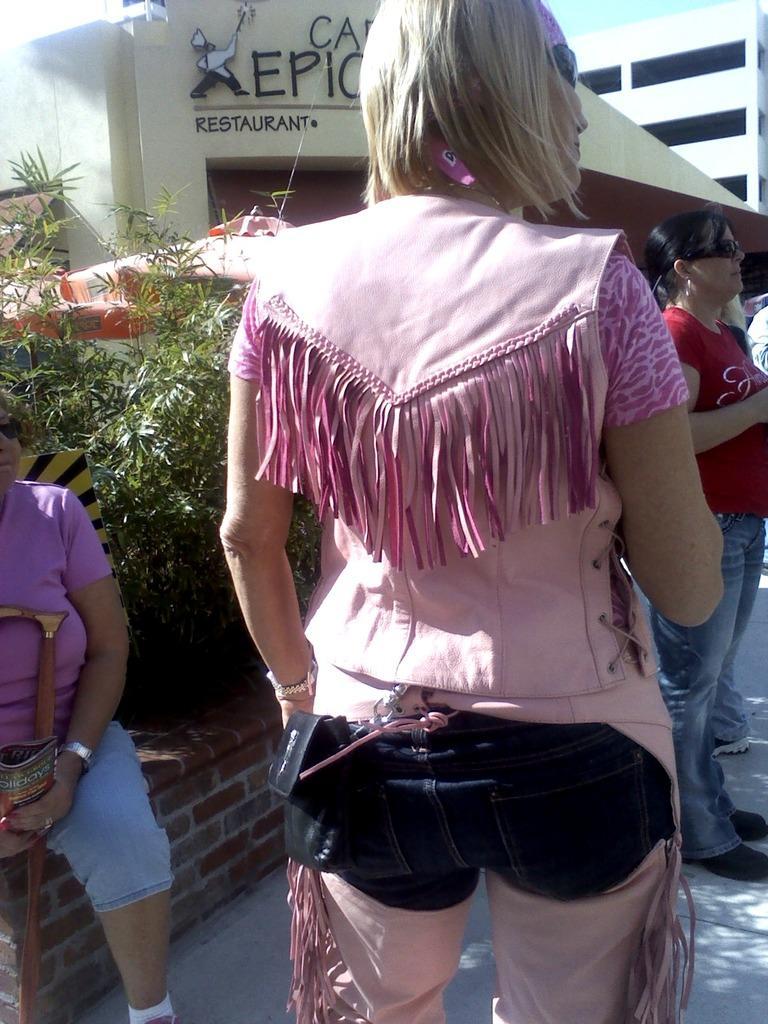Could you give a brief overview of what you see in this image? In this picture there is a man who is wearing pink dress. She is standing near to the another woman who is sitting on the wall, beside her i can see the plants. On the right there is another woman who is wearing goggle, t-shirt, jeans and shoe. In the background i can see the buildings. In the top right there is a sky. 